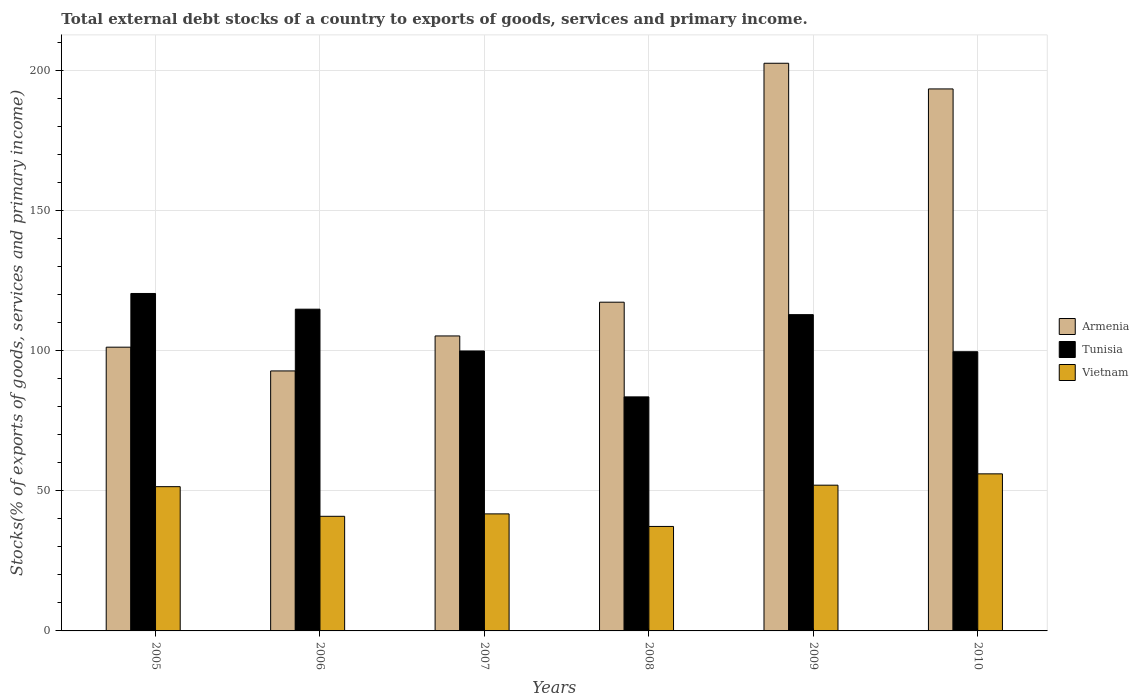Are the number of bars per tick equal to the number of legend labels?
Your answer should be compact. Yes. How many bars are there on the 5th tick from the left?
Offer a terse response. 3. How many bars are there on the 1st tick from the right?
Make the answer very short. 3. What is the label of the 5th group of bars from the left?
Your answer should be compact. 2009. In how many cases, is the number of bars for a given year not equal to the number of legend labels?
Give a very brief answer. 0. What is the total debt stocks in Vietnam in 2007?
Make the answer very short. 41.76. Across all years, what is the maximum total debt stocks in Tunisia?
Keep it short and to the point. 120.41. Across all years, what is the minimum total debt stocks in Armenia?
Make the answer very short. 92.78. In which year was the total debt stocks in Tunisia maximum?
Offer a terse response. 2005. What is the total total debt stocks in Armenia in the graph?
Give a very brief answer. 812.55. What is the difference between the total debt stocks in Vietnam in 2009 and that in 2010?
Your answer should be very brief. -4.04. What is the difference between the total debt stocks in Vietnam in 2008 and the total debt stocks in Armenia in 2006?
Keep it short and to the point. -55.49. What is the average total debt stocks in Tunisia per year?
Provide a short and direct response. 105.19. In the year 2008, what is the difference between the total debt stocks in Tunisia and total debt stocks in Armenia?
Offer a terse response. -33.79. What is the ratio of the total debt stocks in Tunisia in 2007 to that in 2010?
Provide a short and direct response. 1. What is the difference between the highest and the second highest total debt stocks in Armenia?
Provide a succinct answer. 9.16. What is the difference between the highest and the lowest total debt stocks in Armenia?
Offer a very short reply. 109.79. What does the 3rd bar from the left in 2009 represents?
Make the answer very short. Vietnam. What does the 1st bar from the right in 2009 represents?
Provide a succinct answer. Vietnam. Is it the case that in every year, the sum of the total debt stocks in Vietnam and total debt stocks in Tunisia is greater than the total debt stocks in Armenia?
Your response must be concise. No. How many years are there in the graph?
Your response must be concise. 6. Does the graph contain any zero values?
Keep it short and to the point. No. Where does the legend appear in the graph?
Your answer should be compact. Center right. How many legend labels are there?
Offer a very short reply. 3. What is the title of the graph?
Offer a terse response. Total external debt stocks of a country to exports of goods, services and primary income. What is the label or title of the X-axis?
Offer a very short reply. Years. What is the label or title of the Y-axis?
Offer a very short reply. Stocks(% of exports of goods, services and primary income). What is the Stocks(% of exports of goods, services and primary income) of Armenia in 2005?
Your answer should be very brief. 101.25. What is the Stocks(% of exports of goods, services and primary income) in Tunisia in 2005?
Your response must be concise. 120.41. What is the Stocks(% of exports of goods, services and primary income) of Vietnam in 2005?
Keep it short and to the point. 51.47. What is the Stocks(% of exports of goods, services and primary income) in Armenia in 2006?
Your answer should be very brief. 92.78. What is the Stocks(% of exports of goods, services and primary income) of Tunisia in 2006?
Offer a terse response. 114.81. What is the Stocks(% of exports of goods, services and primary income) in Vietnam in 2006?
Offer a very short reply. 40.9. What is the Stocks(% of exports of goods, services and primary income) in Armenia in 2007?
Offer a terse response. 105.26. What is the Stocks(% of exports of goods, services and primary income) in Tunisia in 2007?
Provide a succinct answer. 99.89. What is the Stocks(% of exports of goods, services and primary income) in Vietnam in 2007?
Keep it short and to the point. 41.76. What is the Stocks(% of exports of goods, services and primary income) of Armenia in 2008?
Give a very brief answer. 117.3. What is the Stocks(% of exports of goods, services and primary income) of Tunisia in 2008?
Your answer should be very brief. 83.51. What is the Stocks(% of exports of goods, services and primary income) of Vietnam in 2008?
Provide a short and direct response. 37.28. What is the Stocks(% of exports of goods, services and primary income) of Armenia in 2009?
Make the answer very short. 202.56. What is the Stocks(% of exports of goods, services and primary income) in Tunisia in 2009?
Offer a very short reply. 112.86. What is the Stocks(% of exports of goods, services and primary income) in Vietnam in 2009?
Offer a terse response. 52.01. What is the Stocks(% of exports of goods, services and primary income) in Armenia in 2010?
Give a very brief answer. 193.4. What is the Stocks(% of exports of goods, services and primary income) of Tunisia in 2010?
Your answer should be compact. 99.63. What is the Stocks(% of exports of goods, services and primary income) of Vietnam in 2010?
Keep it short and to the point. 56.05. Across all years, what is the maximum Stocks(% of exports of goods, services and primary income) in Armenia?
Your answer should be very brief. 202.56. Across all years, what is the maximum Stocks(% of exports of goods, services and primary income) in Tunisia?
Ensure brevity in your answer.  120.41. Across all years, what is the maximum Stocks(% of exports of goods, services and primary income) of Vietnam?
Give a very brief answer. 56.05. Across all years, what is the minimum Stocks(% of exports of goods, services and primary income) of Armenia?
Your answer should be compact. 92.78. Across all years, what is the minimum Stocks(% of exports of goods, services and primary income) of Tunisia?
Provide a short and direct response. 83.51. Across all years, what is the minimum Stocks(% of exports of goods, services and primary income) in Vietnam?
Provide a short and direct response. 37.28. What is the total Stocks(% of exports of goods, services and primary income) in Armenia in the graph?
Provide a short and direct response. 812.55. What is the total Stocks(% of exports of goods, services and primary income) in Tunisia in the graph?
Offer a very short reply. 631.12. What is the total Stocks(% of exports of goods, services and primary income) in Vietnam in the graph?
Provide a short and direct response. 279.47. What is the difference between the Stocks(% of exports of goods, services and primary income) in Armenia in 2005 and that in 2006?
Your answer should be compact. 8.48. What is the difference between the Stocks(% of exports of goods, services and primary income) in Tunisia in 2005 and that in 2006?
Your response must be concise. 5.6. What is the difference between the Stocks(% of exports of goods, services and primary income) in Vietnam in 2005 and that in 2006?
Keep it short and to the point. 10.57. What is the difference between the Stocks(% of exports of goods, services and primary income) in Armenia in 2005 and that in 2007?
Give a very brief answer. -4. What is the difference between the Stocks(% of exports of goods, services and primary income) of Tunisia in 2005 and that in 2007?
Give a very brief answer. 20.52. What is the difference between the Stocks(% of exports of goods, services and primary income) of Vietnam in 2005 and that in 2007?
Your answer should be compact. 9.71. What is the difference between the Stocks(% of exports of goods, services and primary income) of Armenia in 2005 and that in 2008?
Your answer should be very brief. -16.05. What is the difference between the Stocks(% of exports of goods, services and primary income) of Tunisia in 2005 and that in 2008?
Ensure brevity in your answer.  36.9. What is the difference between the Stocks(% of exports of goods, services and primary income) of Vietnam in 2005 and that in 2008?
Provide a succinct answer. 14.19. What is the difference between the Stocks(% of exports of goods, services and primary income) of Armenia in 2005 and that in 2009?
Your answer should be very brief. -101.31. What is the difference between the Stocks(% of exports of goods, services and primary income) in Tunisia in 2005 and that in 2009?
Keep it short and to the point. 7.55. What is the difference between the Stocks(% of exports of goods, services and primary income) in Vietnam in 2005 and that in 2009?
Your answer should be compact. -0.53. What is the difference between the Stocks(% of exports of goods, services and primary income) in Armenia in 2005 and that in 2010?
Ensure brevity in your answer.  -92.15. What is the difference between the Stocks(% of exports of goods, services and primary income) of Tunisia in 2005 and that in 2010?
Your answer should be very brief. 20.78. What is the difference between the Stocks(% of exports of goods, services and primary income) in Vietnam in 2005 and that in 2010?
Offer a terse response. -4.57. What is the difference between the Stocks(% of exports of goods, services and primary income) in Armenia in 2006 and that in 2007?
Provide a succinct answer. -12.48. What is the difference between the Stocks(% of exports of goods, services and primary income) of Tunisia in 2006 and that in 2007?
Offer a very short reply. 14.92. What is the difference between the Stocks(% of exports of goods, services and primary income) in Vietnam in 2006 and that in 2007?
Ensure brevity in your answer.  -0.86. What is the difference between the Stocks(% of exports of goods, services and primary income) in Armenia in 2006 and that in 2008?
Your answer should be very brief. -24.53. What is the difference between the Stocks(% of exports of goods, services and primary income) of Tunisia in 2006 and that in 2008?
Offer a terse response. 31.29. What is the difference between the Stocks(% of exports of goods, services and primary income) in Vietnam in 2006 and that in 2008?
Your answer should be compact. 3.62. What is the difference between the Stocks(% of exports of goods, services and primary income) of Armenia in 2006 and that in 2009?
Ensure brevity in your answer.  -109.79. What is the difference between the Stocks(% of exports of goods, services and primary income) in Tunisia in 2006 and that in 2009?
Give a very brief answer. 1.95. What is the difference between the Stocks(% of exports of goods, services and primary income) of Vietnam in 2006 and that in 2009?
Keep it short and to the point. -11.11. What is the difference between the Stocks(% of exports of goods, services and primary income) of Armenia in 2006 and that in 2010?
Your response must be concise. -100.63. What is the difference between the Stocks(% of exports of goods, services and primary income) of Tunisia in 2006 and that in 2010?
Ensure brevity in your answer.  15.18. What is the difference between the Stocks(% of exports of goods, services and primary income) in Vietnam in 2006 and that in 2010?
Keep it short and to the point. -15.14. What is the difference between the Stocks(% of exports of goods, services and primary income) of Armenia in 2007 and that in 2008?
Keep it short and to the point. -12.05. What is the difference between the Stocks(% of exports of goods, services and primary income) of Tunisia in 2007 and that in 2008?
Provide a short and direct response. 16.38. What is the difference between the Stocks(% of exports of goods, services and primary income) of Vietnam in 2007 and that in 2008?
Make the answer very short. 4.48. What is the difference between the Stocks(% of exports of goods, services and primary income) in Armenia in 2007 and that in 2009?
Give a very brief answer. -97.31. What is the difference between the Stocks(% of exports of goods, services and primary income) in Tunisia in 2007 and that in 2009?
Provide a short and direct response. -12.97. What is the difference between the Stocks(% of exports of goods, services and primary income) in Vietnam in 2007 and that in 2009?
Provide a succinct answer. -10.25. What is the difference between the Stocks(% of exports of goods, services and primary income) in Armenia in 2007 and that in 2010?
Provide a short and direct response. -88.15. What is the difference between the Stocks(% of exports of goods, services and primary income) of Tunisia in 2007 and that in 2010?
Ensure brevity in your answer.  0.26. What is the difference between the Stocks(% of exports of goods, services and primary income) of Vietnam in 2007 and that in 2010?
Ensure brevity in your answer.  -14.29. What is the difference between the Stocks(% of exports of goods, services and primary income) of Armenia in 2008 and that in 2009?
Keep it short and to the point. -85.26. What is the difference between the Stocks(% of exports of goods, services and primary income) in Tunisia in 2008 and that in 2009?
Give a very brief answer. -29.34. What is the difference between the Stocks(% of exports of goods, services and primary income) in Vietnam in 2008 and that in 2009?
Your answer should be compact. -14.72. What is the difference between the Stocks(% of exports of goods, services and primary income) in Armenia in 2008 and that in 2010?
Offer a very short reply. -76.1. What is the difference between the Stocks(% of exports of goods, services and primary income) in Tunisia in 2008 and that in 2010?
Offer a very short reply. -16.11. What is the difference between the Stocks(% of exports of goods, services and primary income) in Vietnam in 2008 and that in 2010?
Provide a succinct answer. -18.76. What is the difference between the Stocks(% of exports of goods, services and primary income) in Armenia in 2009 and that in 2010?
Your answer should be very brief. 9.16. What is the difference between the Stocks(% of exports of goods, services and primary income) of Tunisia in 2009 and that in 2010?
Offer a very short reply. 13.23. What is the difference between the Stocks(% of exports of goods, services and primary income) of Vietnam in 2009 and that in 2010?
Provide a short and direct response. -4.04. What is the difference between the Stocks(% of exports of goods, services and primary income) in Armenia in 2005 and the Stocks(% of exports of goods, services and primary income) in Tunisia in 2006?
Ensure brevity in your answer.  -13.56. What is the difference between the Stocks(% of exports of goods, services and primary income) in Armenia in 2005 and the Stocks(% of exports of goods, services and primary income) in Vietnam in 2006?
Ensure brevity in your answer.  60.35. What is the difference between the Stocks(% of exports of goods, services and primary income) of Tunisia in 2005 and the Stocks(% of exports of goods, services and primary income) of Vietnam in 2006?
Your answer should be compact. 79.51. What is the difference between the Stocks(% of exports of goods, services and primary income) in Armenia in 2005 and the Stocks(% of exports of goods, services and primary income) in Tunisia in 2007?
Give a very brief answer. 1.36. What is the difference between the Stocks(% of exports of goods, services and primary income) of Armenia in 2005 and the Stocks(% of exports of goods, services and primary income) of Vietnam in 2007?
Your answer should be very brief. 59.49. What is the difference between the Stocks(% of exports of goods, services and primary income) in Tunisia in 2005 and the Stocks(% of exports of goods, services and primary income) in Vietnam in 2007?
Offer a very short reply. 78.65. What is the difference between the Stocks(% of exports of goods, services and primary income) of Armenia in 2005 and the Stocks(% of exports of goods, services and primary income) of Tunisia in 2008?
Ensure brevity in your answer.  17.74. What is the difference between the Stocks(% of exports of goods, services and primary income) of Armenia in 2005 and the Stocks(% of exports of goods, services and primary income) of Vietnam in 2008?
Your answer should be very brief. 63.97. What is the difference between the Stocks(% of exports of goods, services and primary income) in Tunisia in 2005 and the Stocks(% of exports of goods, services and primary income) in Vietnam in 2008?
Your answer should be very brief. 83.13. What is the difference between the Stocks(% of exports of goods, services and primary income) of Armenia in 2005 and the Stocks(% of exports of goods, services and primary income) of Tunisia in 2009?
Offer a terse response. -11.61. What is the difference between the Stocks(% of exports of goods, services and primary income) of Armenia in 2005 and the Stocks(% of exports of goods, services and primary income) of Vietnam in 2009?
Provide a short and direct response. 49.25. What is the difference between the Stocks(% of exports of goods, services and primary income) of Tunisia in 2005 and the Stocks(% of exports of goods, services and primary income) of Vietnam in 2009?
Ensure brevity in your answer.  68.41. What is the difference between the Stocks(% of exports of goods, services and primary income) in Armenia in 2005 and the Stocks(% of exports of goods, services and primary income) in Tunisia in 2010?
Make the answer very short. 1.62. What is the difference between the Stocks(% of exports of goods, services and primary income) in Armenia in 2005 and the Stocks(% of exports of goods, services and primary income) in Vietnam in 2010?
Your response must be concise. 45.21. What is the difference between the Stocks(% of exports of goods, services and primary income) of Tunisia in 2005 and the Stocks(% of exports of goods, services and primary income) of Vietnam in 2010?
Provide a short and direct response. 64.37. What is the difference between the Stocks(% of exports of goods, services and primary income) of Armenia in 2006 and the Stocks(% of exports of goods, services and primary income) of Tunisia in 2007?
Ensure brevity in your answer.  -7.12. What is the difference between the Stocks(% of exports of goods, services and primary income) in Armenia in 2006 and the Stocks(% of exports of goods, services and primary income) in Vietnam in 2007?
Give a very brief answer. 51.01. What is the difference between the Stocks(% of exports of goods, services and primary income) in Tunisia in 2006 and the Stocks(% of exports of goods, services and primary income) in Vietnam in 2007?
Offer a very short reply. 73.05. What is the difference between the Stocks(% of exports of goods, services and primary income) of Armenia in 2006 and the Stocks(% of exports of goods, services and primary income) of Tunisia in 2008?
Make the answer very short. 9.26. What is the difference between the Stocks(% of exports of goods, services and primary income) in Armenia in 2006 and the Stocks(% of exports of goods, services and primary income) in Vietnam in 2008?
Ensure brevity in your answer.  55.49. What is the difference between the Stocks(% of exports of goods, services and primary income) in Tunisia in 2006 and the Stocks(% of exports of goods, services and primary income) in Vietnam in 2008?
Keep it short and to the point. 77.53. What is the difference between the Stocks(% of exports of goods, services and primary income) of Armenia in 2006 and the Stocks(% of exports of goods, services and primary income) of Tunisia in 2009?
Ensure brevity in your answer.  -20.08. What is the difference between the Stocks(% of exports of goods, services and primary income) of Armenia in 2006 and the Stocks(% of exports of goods, services and primary income) of Vietnam in 2009?
Provide a succinct answer. 40.77. What is the difference between the Stocks(% of exports of goods, services and primary income) of Tunisia in 2006 and the Stocks(% of exports of goods, services and primary income) of Vietnam in 2009?
Make the answer very short. 62.8. What is the difference between the Stocks(% of exports of goods, services and primary income) of Armenia in 2006 and the Stocks(% of exports of goods, services and primary income) of Tunisia in 2010?
Your answer should be very brief. -6.85. What is the difference between the Stocks(% of exports of goods, services and primary income) of Armenia in 2006 and the Stocks(% of exports of goods, services and primary income) of Vietnam in 2010?
Offer a very short reply. 36.73. What is the difference between the Stocks(% of exports of goods, services and primary income) in Tunisia in 2006 and the Stocks(% of exports of goods, services and primary income) in Vietnam in 2010?
Offer a very short reply. 58.76. What is the difference between the Stocks(% of exports of goods, services and primary income) of Armenia in 2007 and the Stocks(% of exports of goods, services and primary income) of Tunisia in 2008?
Offer a very short reply. 21.74. What is the difference between the Stocks(% of exports of goods, services and primary income) of Armenia in 2007 and the Stocks(% of exports of goods, services and primary income) of Vietnam in 2008?
Give a very brief answer. 67.97. What is the difference between the Stocks(% of exports of goods, services and primary income) of Tunisia in 2007 and the Stocks(% of exports of goods, services and primary income) of Vietnam in 2008?
Keep it short and to the point. 62.61. What is the difference between the Stocks(% of exports of goods, services and primary income) in Armenia in 2007 and the Stocks(% of exports of goods, services and primary income) in Tunisia in 2009?
Your answer should be compact. -7.6. What is the difference between the Stocks(% of exports of goods, services and primary income) in Armenia in 2007 and the Stocks(% of exports of goods, services and primary income) in Vietnam in 2009?
Offer a very short reply. 53.25. What is the difference between the Stocks(% of exports of goods, services and primary income) in Tunisia in 2007 and the Stocks(% of exports of goods, services and primary income) in Vietnam in 2009?
Provide a short and direct response. 47.89. What is the difference between the Stocks(% of exports of goods, services and primary income) of Armenia in 2007 and the Stocks(% of exports of goods, services and primary income) of Tunisia in 2010?
Your answer should be compact. 5.63. What is the difference between the Stocks(% of exports of goods, services and primary income) in Armenia in 2007 and the Stocks(% of exports of goods, services and primary income) in Vietnam in 2010?
Provide a short and direct response. 49.21. What is the difference between the Stocks(% of exports of goods, services and primary income) of Tunisia in 2007 and the Stocks(% of exports of goods, services and primary income) of Vietnam in 2010?
Ensure brevity in your answer.  43.85. What is the difference between the Stocks(% of exports of goods, services and primary income) in Armenia in 2008 and the Stocks(% of exports of goods, services and primary income) in Tunisia in 2009?
Your answer should be compact. 4.44. What is the difference between the Stocks(% of exports of goods, services and primary income) in Armenia in 2008 and the Stocks(% of exports of goods, services and primary income) in Vietnam in 2009?
Keep it short and to the point. 65.3. What is the difference between the Stocks(% of exports of goods, services and primary income) of Tunisia in 2008 and the Stocks(% of exports of goods, services and primary income) of Vietnam in 2009?
Offer a terse response. 31.51. What is the difference between the Stocks(% of exports of goods, services and primary income) of Armenia in 2008 and the Stocks(% of exports of goods, services and primary income) of Tunisia in 2010?
Your answer should be very brief. 17.67. What is the difference between the Stocks(% of exports of goods, services and primary income) of Armenia in 2008 and the Stocks(% of exports of goods, services and primary income) of Vietnam in 2010?
Provide a succinct answer. 61.26. What is the difference between the Stocks(% of exports of goods, services and primary income) in Tunisia in 2008 and the Stocks(% of exports of goods, services and primary income) in Vietnam in 2010?
Your answer should be very brief. 27.47. What is the difference between the Stocks(% of exports of goods, services and primary income) of Armenia in 2009 and the Stocks(% of exports of goods, services and primary income) of Tunisia in 2010?
Provide a succinct answer. 102.93. What is the difference between the Stocks(% of exports of goods, services and primary income) of Armenia in 2009 and the Stocks(% of exports of goods, services and primary income) of Vietnam in 2010?
Your answer should be compact. 146.52. What is the difference between the Stocks(% of exports of goods, services and primary income) of Tunisia in 2009 and the Stocks(% of exports of goods, services and primary income) of Vietnam in 2010?
Offer a very short reply. 56.81. What is the average Stocks(% of exports of goods, services and primary income) of Armenia per year?
Provide a succinct answer. 135.43. What is the average Stocks(% of exports of goods, services and primary income) in Tunisia per year?
Offer a very short reply. 105.19. What is the average Stocks(% of exports of goods, services and primary income) in Vietnam per year?
Make the answer very short. 46.58. In the year 2005, what is the difference between the Stocks(% of exports of goods, services and primary income) in Armenia and Stocks(% of exports of goods, services and primary income) in Tunisia?
Keep it short and to the point. -19.16. In the year 2005, what is the difference between the Stocks(% of exports of goods, services and primary income) in Armenia and Stocks(% of exports of goods, services and primary income) in Vietnam?
Provide a succinct answer. 49.78. In the year 2005, what is the difference between the Stocks(% of exports of goods, services and primary income) in Tunisia and Stocks(% of exports of goods, services and primary income) in Vietnam?
Keep it short and to the point. 68.94. In the year 2006, what is the difference between the Stocks(% of exports of goods, services and primary income) of Armenia and Stocks(% of exports of goods, services and primary income) of Tunisia?
Your answer should be compact. -22.03. In the year 2006, what is the difference between the Stocks(% of exports of goods, services and primary income) of Armenia and Stocks(% of exports of goods, services and primary income) of Vietnam?
Provide a short and direct response. 51.87. In the year 2006, what is the difference between the Stocks(% of exports of goods, services and primary income) in Tunisia and Stocks(% of exports of goods, services and primary income) in Vietnam?
Provide a short and direct response. 73.91. In the year 2007, what is the difference between the Stocks(% of exports of goods, services and primary income) in Armenia and Stocks(% of exports of goods, services and primary income) in Tunisia?
Ensure brevity in your answer.  5.36. In the year 2007, what is the difference between the Stocks(% of exports of goods, services and primary income) of Armenia and Stocks(% of exports of goods, services and primary income) of Vietnam?
Your answer should be very brief. 63.5. In the year 2007, what is the difference between the Stocks(% of exports of goods, services and primary income) in Tunisia and Stocks(% of exports of goods, services and primary income) in Vietnam?
Make the answer very short. 58.13. In the year 2008, what is the difference between the Stocks(% of exports of goods, services and primary income) in Armenia and Stocks(% of exports of goods, services and primary income) in Tunisia?
Ensure brevity in your answer.  33.79. In the year 2008, what is the difference between the Stocks(% of exports of goods, services and primary income) in Armenia and Stocks(% of exports of goods, services and primary income) in Vietnam?
Ensure brevity in your answer.  80.02. In the year 2008, what is the difference between the Stocks(% of exports of goods, services and primary income) in Tunisia and Stocks(% of exports of goods, services and primary income) in Vietnam?
Make the answer very short. 46.23. In the year 2009, what is the difference between the Stocks(% of exports of goods, services and primary income) in Armenia and Stocks(% of exports of goods, services and primary income) in Tunisia?
Provide a short and direct response. 89.7. In the year 2009, what is the difference between the Stocks(% of exports of goods, services and primary income) in Armenia and Stocks(% of exports of goods, services and primary income) in Vietnam?
Make the answer very short. 150.56. In the year 2009, what is the difference between the Stocks(% of exports of goods, services and primary income) in Tunisia and Stocks(% of exports of goods, services and primary income) in Vietnam?
Keep it short and to the point. 60.85. In the year 2010, what is the difference between the Stocks(% of exports of goods, services and primary income) of Armenia and Stocks(% of exports of goods, services and primary income) of Tunisia?
Give a very brief answer. 93.77. In the year 2010, what is the difference between the Stocks(% of exports of goods, services and primary income) in Armenia and Stocks(% of exports of goods, services and primary income) in Vietnam?
Make the answer very short. 137.36. In the year 2010, what is the difference between the Stocks(% of exports of goods, services and primary income) of Tunisia and Stocks(% of exports of goods, services and primary income) of Vietnam?
Ensure brevity in your answer.  43.58. What is the ratio of the Stocks(% of exports of goods, services and primary income) of Armenia in 2005 to that in 2006?
Keep it short and to the point. 1.09. What is the ratio of the Stocks(% of exports of goods, services and primary income) in Tunisia in 2005 to that in 2006?
Your response must be concise. 1.05. What is the ratio of the Stocks(% of exports of goods, services and primary income) in Vietnam in 2005 to that in 2006?
Keep it short and to the point. 1.26. What is the ratio of the Stocks(% of exports of goods, services and primary income) of Armenia in 2005 to that in 2007?
Keep it short and to the point. 0.96. What is the ratio of the Stocks(% of exports of goods, services and primary income) of Tunisia in 2005 to that in 2007?
Offer a terse response. 1.21. What is the ratio of the Stocks(% of exports of goods, services and primary income) of Vietnam in 2005 to that in 2007?
Offer a very short reply. 1.23. What is the ratio of the Stocks(% of exports of goods, services and primary income) of Armenia in 2005 to that in 2008?
Ensure brevity in your answer.  0.86. What is the ratio of the Stocks(% of exports of goods, services and primary income) of Tunisia in 2005 to that in 2008?
Your answer should be compact. 1.44. What is the ratio of the Stocks(% of exports of goods, services and primary income) of Vietnam in 2005 to that in 2008?
Make the answer very short. 1.38. What is the ratio of the Stocks(% of exports of goods, services and primary income) of Armenia in 2005 to that in 2009?
Keep it short and to the point. 0.5. What is the ratio of the Stocks(% of exports of goods, services and primary income) in Tunisia in 2005 to that in 2009?
Your answer should be very brief. 1.07. What is the ratio of the Stocks(% of exports of goods, services and primary income) of Armenia in 2005 to that in 2010?
Offer a very short reply. 0.52. What is the ratio of the Stocks(% of exports of goods, services and primary income) in Tunisia in 2005 to that in 2010?
Your response must be concise. 1.21. What is the ratio of the Stocks(% of exports of goods, services and primary income) of Vietnam in 2005 to that in 2010?
Your response must be concise. 0.92. What is the ratio of the Stocks(% of exports of goods, services and primary income) of Armenia in 2006 to that in 2007?
Provide a succinct answer. 0.88. What is the ratio of the Stocks(% of exports of goods, services and primary income) in Tunisia in 2006 to that in 2007?
Your answer should be compact. 1.15. What is the ratio of the Stocks(% of exports of goods, services and primary income) in Vietnam in 2006 to that in 2007?
Your answer should be very brief. 0.98. What is the ratio of the Stocks(% of exports of goods, services and primary income) in Armenia in 2006 to that in 2008?
Offer a terse response. 0.79. What is the ratio of the Stocks(% of exports of goods, services and primary income) of Tunisia in 2006 to that in 2008?
Give a very brief answer. 1.37. What is the ratio of the Stocks(% of exports of goods, services and primary income) in Vietnam in 2006 to that in 2008?
Provide a short and direct response. 1.1. What is the ratio of the Stocks(% of exports of goods, services and primary income) of Armenia in 2006 to that in 2009?
Your answer should be very brief. 0.46. What is the ratio of the Stocks(% of exports of goods, services and primary income) of Tunisia in 2006 to that in 2009?
Give a very brief answer. 1.02. What is the ratio of the Stocks(% of exports of goods, services and primary income) of Vietnam in 2006 to that in 2009?
Provide a short and direct response. 0.79. What is the ratio of the Stocks(% of exports of goods, services and primary income) in Armenia in 2006 to that in 2010?
Give a very brief answer. 0.48. What is the ratio of the Stocks(% of exports of goods, services and primary income) in Tunisia in 2006 to that in 2010?
Provide a short and direct response. 1.15. What is the ratio of the Stocks(% of exports of goods, services and primary income) in Vietnam in 2006 to that in 2010?
Provide a succinct answer. 0.73. What is the ratio of the Stocks(% of exports of goods, services and primary income) of Armenia in 2007 to that in 2008?
Offer a terse response. 0.9. What is the ratio of the Stocks(% of exports of goods, services and primary income) in Tunisia in 2007 to that in 2008?
Give a very brief answer. 1.2. What is the ratio of the Stocks(% of exports of goods, services and primary income) in Vietnam in 2007 to that in 2008?
Give a very brief answer. 1.12. What is the ratio of the Stocks(% of exports of goods, services and primary income) in Armenia in 2007 to that in 2009?
Offer a terse response. 0.52. What is the ratio of the Stocks(% of exports of goods, services and primary income) of Tunisia in 2007 to that in 2009?
Ensure brevity in your answer.  0.89. What is the ratio of the Stocks(% of exports of goods, services and primary income) of Vietnam in 2007 to that in 2009?
Keep it short and to the point. 0.8. What is the ratio of the Stocks(% of exports of goods, services and primary income) of Armenia in 2007 to that in 2010?
Ensure brevity in your answer.  0.54. What is the ratio of the Stocks(% of exports of goods, services and primary income) in Tunisia in 2007 to that in 2010?
Give a very brief answer. 1. What is the ratio of the Stocks(% of exports of goods, services and primary income) of Vietnam in 2007 to that in 2010?
Provide a succinct answer. 0.75. What is the ratio of the Stocks(% of exports of goods, services and primary income) of Armenia in 2008 to that in 2009?
Give a very brief answer. 0.58. What is the ratio of the Stocks(% of exports of goods, services and primary income) in Tunisia in 2008 to that in 2009?
Provide a short and direct response. 0.74. What is the ratio of the Stocks(% of exports of goods, services and primary income) of Vietnam in 2008 to that in 2009?
Provide a short and direct response. 0.72. What is the ratio of the Stocks(% of exports of goods, services and primary income) in Armenia in 2008 to that in 2010?
Provide a short and direct response. 0.61. What is the ratio of the Stocks(% of exports of goods, services and primary income) in Tunisia in 2008 to that in 2010?
Your response must be concise. 0.84. What is the ratio of the Stocks(% of exports of goods, services and primary income) of Vietnam in 2008 to that in 2010?
Give a very brief answer. 0.67. What is the ratio of the Stocks(% of exports of goods, services and primary income) of Armenia in 2009 to that in 2010?
Offer a very short reply. 1.05. What is the ratio of the Stocks(% of exports of goods, services and primary income) in Tunisia in 2009 to that in 2010?
Ensure brevity in your answer.  1.13. What is the ratio of the Stocks(% of exports of goods, services and primary income) in Vietnam in 2009 to that in 2010?
Give a very brief answer. 0.93. What is the difference between the highest and the second highest Stocks(% of exports of goods, services and primary income) of Armenia?
Ensure brevity in your answer.  9.16. What is the difference between the highest and the second highest Stocks(% of exports of goods, services and primary income) in Tunisia?
Your answer should be compact. 5.6. What is the difference between the highest and the second highest Stocks(% of exports of goods, services and primary income) in Vietnam?
Make the answer very short. 4.04. What is the difference between the highest and the lowest Stocks(% of exports of goods, services and primary income) of Armenia?
Provide a succinct answer. 109.79. What is the difference between the highest and the lowest Stocks(% of exports of goods, services and primary income) of Tunisia?
Your answer should be very brief. 36.9. What is the difference between the highest and the lowest Stocks(% of exports of goods, services and primary income) of Vietnam?
Your answer should be compact. 18.76. 